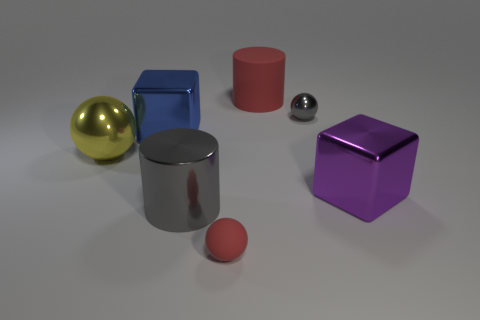What shape is the thing that is the same color as the metallic cylinder?
Provide a succinct answer. Sphere. There is a red rubber thing that is behind the tiny gray shiny ball; what shape is it?
Your answer should be very brief. Cylinder. There is a metal object that is on the right side of the tiny gray shiny thing; does it have the same shape as the tiny gray object?
Provide a succinct answer. No. What number of things are shiny things that are left of the red cylinder or large blue metal blocks?
Offer a very short reply. 3. The big metallic thing that is the same shape as the big red matte thing is what color?
Offer a very short reply. Gray. Are there any other things that have the same color as the matte ball?
Keep it short and to the point. Yes. How big is the shiny block that is left of the matte cylinder?
Your answer should be compact. Large. There is a tiny shiny ball; is its color the same as the large block that is to the left of the tiny red matte object?
Offer a terse response. No. How many other objects are the same material as the gray sphere?
Ensure brevity in your answer.  4. Is the number of big blue shiny blocks greater than the number of yellow rubber objects?
Your response must be concise. Yes. 